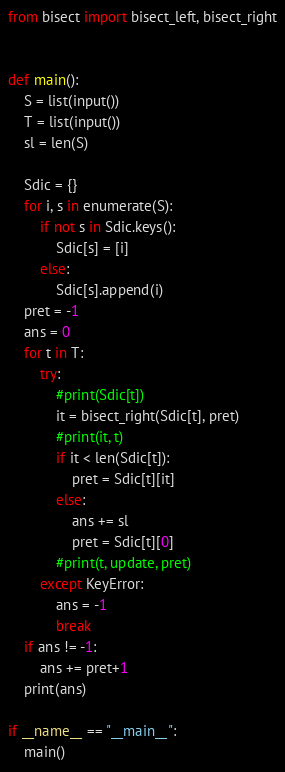Convert code to text. <code><loc_0><loc_0><loc_500><loc_500><_Python_>from bisect import bisect_left, bisect_right


def main():
    S = list(input())
    T = list(input())
    sl = len(S)

    Sdic = {}
    for i, s in enumerate(S):
        if not s in Sdic.keys():
            Sdic[s] = [i]
        else:
            Sdic[s].append(i)
    pret = -1
    ans = 0
    for t in T:
        try:
            #print(Sdic[t])
            it = bisect_right(Sdic[t], pret)
            #print(it, t)
            if it < len(Sdic[t]):
                pret = Sdic[t][it]
            else:
                ans += sl
                pret = Sdic[t][0]
            #print(t, update, pret)
        except KeyError:
            ans = -1
            break
    if ans != -1:
        ans += pret+1
    print(ans)

if __name__ == "__main__":
    main()</code> 